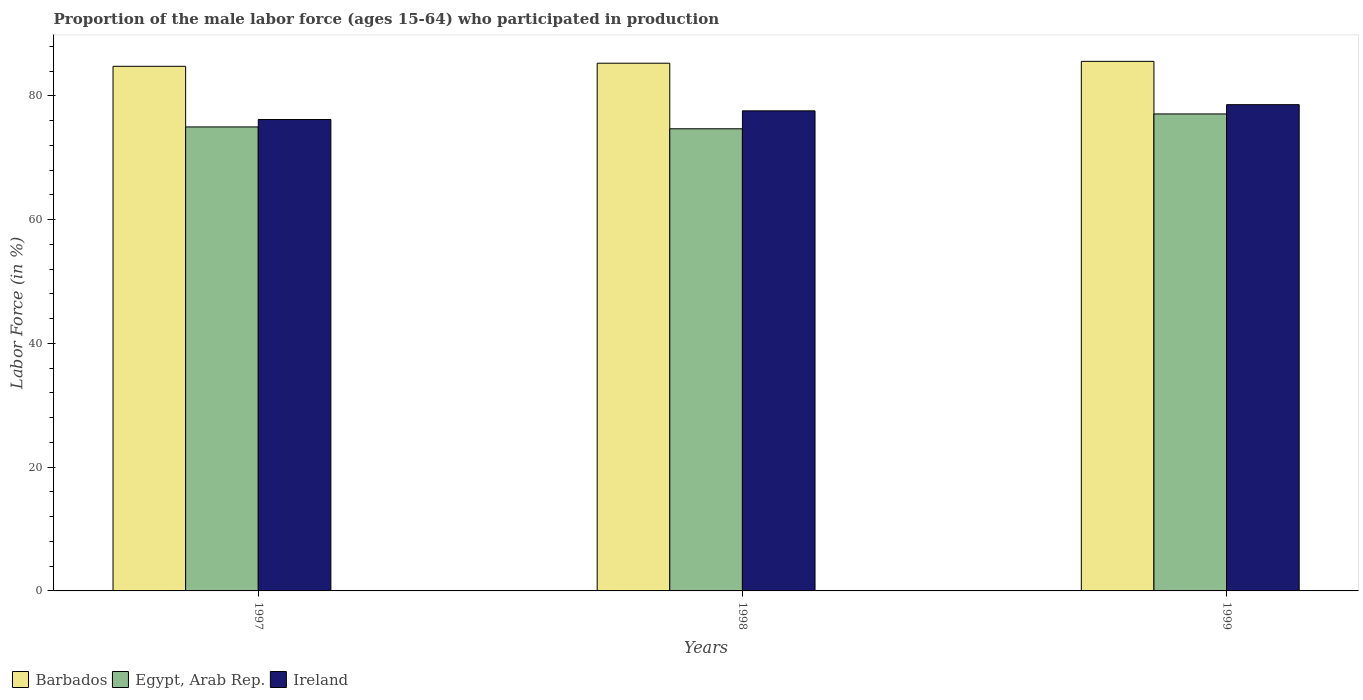How many different coloured bars are there?
Make the answer very short. 3. Are the number of bars per tick equal to the number of legend labels?
Offer a terse response. Yes. Are the number of bars on each tick of the X-axis equal?
Your response must be concise. Yes. What is the label of the 1st group of bars from the left?
Give a very brief answer. 1997. In how many cases, is the number of bars for a given year not equal to the number of legend labels?
Provide a short and direct response. 0. What is the proportion of the male labor force who participated in production in Ireland in 1998?
Offer a very short reply. 77.6. Across all years, what is the maximum proportion of the male labor force who participated in production in Ireland?
Provide a short and direct response. 78.6. Across all years, what is the minimum proportion of the male labor force who participated in production in Ireland?
Provide a short and direct response. 76.2. In which year was the proportion of the male labor force who participated in production in Ireland maximum?
Make the answer very short. 1999. In which year was the proportion of the male labor force who participated in production in Egypt, Arab Rep. minimum?
Make the answer very short. 1998. What is the total proportion of the male labor force who participated in production in Barbados in the graph?
Keep it short and to the point. 255.7. What is the difference between the proportion of the male labor force who participated in production in Ireland in 1998 and that in 1999?
Provide a succinct answer. -1. What is the difference between the proportion of the male labor force who participated in production in Ireland in 1997 and the proportion of the male labor force who participated in production in Barbados in 1998?
Your answer should be very brief. -9.1. What is the average proportion of the male labor force who participated in production in Egypt, Arab Rep. per year?
Your answer should be compact. 75.6. In the year 1999, what is the difference between the proportion of the male labor force who participated in production in Egypt, Arab Rep. and proportion of the male labor force who participated in production in Barbados?
Your answer should be compact. -8.5. What is the ratio of the proportion of the male labor force who participated in production in Ireland in 1997 to that in 1998?
Provide a succinct answer. 0.98. Is the proportion of the male labor force who participated in production in Barbados in 1997 less than that in 1998?
Ensure brevity in your answer.  Yes. What is the difference between the highest and the second highest proportion of the male labor force who participated in production in Ireland?
Provide a succinct answer. 1. What is the difference between the highest and the lowest proportion of the male labor force who participated in production in Barbados?
Ensure brevity in your answer.  0.8. In how many years, is the proportion of the male labor force who participated in production in Barbados greater than the average proportion of the male labor force who participated in production in Barbados taken over all years?
Offer a very short reply. 2. What does the 3rd bar from the left in 1998 represents?
Keep it short and to the point. Ireland. What does the 2nd bar from the right in 1999 represents?
Your answer should be very brief. Egypt, Arab Rep. How many bars are there?
Offer a very short reply. 9. What is the difference between two consecutive major ticks on the Y-axis?
Give a very brief answer. 20. Are the values on the major ticks of Y-axis written in scientific E-notation?
Your answer should be very brief. No. Does the graph contain any zero values?
Your response must be concise. No. How many legend labels are there?
Your answer should be compact. 3. How are the legend labels stacked?
Ensure brevity in your answer.  Horizontal. What is the title of the graph?
Give a very brief answer. Proportion of the male labor force (ages 15-64) who participated in production. What is the Labor Force (in %) in Barbados in 1997?
Provide a succinct answer. 84.8. What is the Labor Force (in %) of Egypt, Arab Rep. in 1997?
Offer a very short reply. 75. What is the Labor Force (in %) in Ireland in 1997?
Your response must be concise. 76.2. What is the Labor Force (in %) in Barbados in 1998?
Keep it short and to the point. 85.3. What is the Labor Force (in %) of Egypt, Arab Rep. in 1998?
Give a very brief answer. 74.7. What is the Labor Force (in %) in Ireland in 1998?
Make the answer very short. 77.6. What is the Labor Force (in %) of Barbados in 1999?
Provide a short and direct response. 85.6. What is the Labor Force (in %) in Egypt, Arab Rep. in 1999?
Your response must be concise. 77.1. What is the Labor Force (in %) of Ireland in 1999?
Give a very brief answer. 78.6. Across all years, what is the maximum Labor Force (in %) in Barbados?
Provide a succinct answer. 85.6. Across all years, what is the maximum Labor Force (in %) of Egypt, Arab Rep.?
Give a very brief answer. 77.1. Across all years, what is the maximum Labor Force (in %) in Ireland?
Offer a very short reply. 78.6. Across all years, what is the minimum Labor Force (in %) in Barbados?
Your response must be concise. 84.8. Across all years, what is the minimum Labor Force (in %) of Egypt, Arab Rep.?
Ensure brevity in your answer.  74.7. Across all years, what is the minimum Labor Force (in %) of Ireland?
Give a very brief answer. 76.2. What is the total Labor Force (in %) in Barbados in the graph?
Make the answer very short. 255.7. What is the total Labor Force (in %) in Egypt, Arab Rep. in the graph?
Provide a succinct answer. 226.8. What is the total Labor Force (in %) in Ireland in the graph?
Your response must be concise. 232.4. What is the difference between the Labor Force (in %) in Ireland in 1997 and that in 1998?
Provide a short and direct response. -1.4. What is the difference between the Labor Force (in %) of Egypt, Arab Rep. in 1997 and that in 1999?
Your answer should be very brief. -2.1. What is the difference between the Labor Force (in %) of Ireland in 1997 and that in 1999?
Offer a very short reply. -2.4. What is the difference between the Labor Force (in %) in Barbados in 1998 and that in 1999?
Your answer should be compact. -0.3. What is the difference between the Labor Force (in %) in Egypt, Arab Rep. in 1998 and that in 1999?
Give a very brief answer. -2.4. What is the difference between the Labor Force (in %) in Barbados in 1997 and the Labor Force (in %) in Ireland in 1998?
Provide a short and direct response. 7.2. What is the difference between the Labor Force (in %) of Egypt, Arab Rep. in 1997 and the Labor Force (in %) of Ireland in 1998?
Give a very brief answer. -2.6. What is the difference between the Labor Force (in %) of Barbados in 1997 and the Labor Force (in %) of Egypt, Arab Rep. in 1999?
Provide a succinct answer. 7.7. What is the difference between the Labor Force (in %) in Barbados in 1997 and the Labor Force (in %) in Ireland in 1999?
Make the answer very short. 6.2. What is the difference between the Labor Force (in %) of Barbados in 1998 and the Labor Force (in %) of Egypt, Arab Rep. in 1999?
Keep it short and to the point. 8.2. What is the difference between the Labor Force (in %) in Egypt, Arab Rep. in 1998 and the Labor Force (in %) in Ireland in 1999?
Make the answer very short. -3.9. What is the average Labor Force (in %) of Barbados per year?
Make the answer very short. 85.23. What is the average Labor Force (in %) of Egypt, Arab Rep. per year?
Your answer should be very brief. 75.6. What is the average Labor Force (in %) of Ireland per year?
Ensure brevity in your answer.  77.47. In the year 1997, what is the difference between the Labor Force (in %) in Barbados and Labor Force (in %) in Egypt, Arab Rep.?
Your response must be concise. 9.8. In the year 1997, what is the difference between the Labor Force (in %) of Barbados and Labor Force (in %) of Ireland?
Keep it short and to the point. 8.6. In the year 1997, what is the difference between the Labor Force (in %) of Egypt, Arab Rep. and Labor Force (in %) of Ireland?
Your answer should be compact. -1.2. In the year 1998, what is the difference between the Labor Force (in %) of Barbados and Labor Force (in %) of Egypt, Arab Rep.?
Ensure brevity in your answer.  10.6. In the year 1998, what is the difference between the Labor Force (in %) in Egypt, Arab Rep. and Labor Force (in %) in Ireland?
Offer a very short reply. -2.9. In the year 1999, what is the difference between the Labor Force (in %) of Barbados and Labor Force (in %) of Egypt, Arab Rep.?
Provide a succinct answer. 8.5. In the year 1999, what is the difference between the Labor Force (in %) of Barbados and Labor Force (in %) of Ireland?
Give a very brief answer. 7. In the year 1999, what is the difference between the Labor Force (in %) of Egypt, Arab Rep. and Labor Force (in %) of Ireland?
Make the answer very short. -1.5. What is the ratio of the Labor Force (in %) of Barbados in 1997 to that in 1998?
Your answer should be very brief. 0.99. What is the ratio of the Labor Force (in %) of Egypt, Arab Rep. in 1997 to that in 1998?
Make the answer very short. 1. What is the ratio of the Labor Force (in %) of Ireland in 1997 to that in 1998?
Make the answer very short. 0.98. What is the ratio of the Labor Force (in %) of Egypt, Arab Rep. in 1997 to that in 1999?
Keep it short and to the point. 0.97. What is the ratio of the Labor Force (in %) in Ireland in 1997 to that in 1999?
Give a very brief answer. 0.97. What is the ratio of the Labor Force (in %) of Barbados in 1998 to that in 1999?
Your answer should be compact. 1. What is the ratio of the Labor Force (in %) of Egypt, Arab Rep. in 1998 to that in 1999?
Offer a very short reply. 0.97. What is the ratio of the Labor Force (in %) of Ireland in 1998 to that in 1999?
Provide a succinct answer. 0.99. What is the difference between the highest and the second highest Labor Force (in %) of Barbados?
Provide a succinct answer. 0.3. What is the difference between the highest and the lowest Labor Force (in %) in Egypt, Arab Rep.?
Ensure brevity in your answer.  2.4. What is the difference between the highest and the lowest Labor Force (in %) of Ireland?
Your response must be concise. 2.4. 